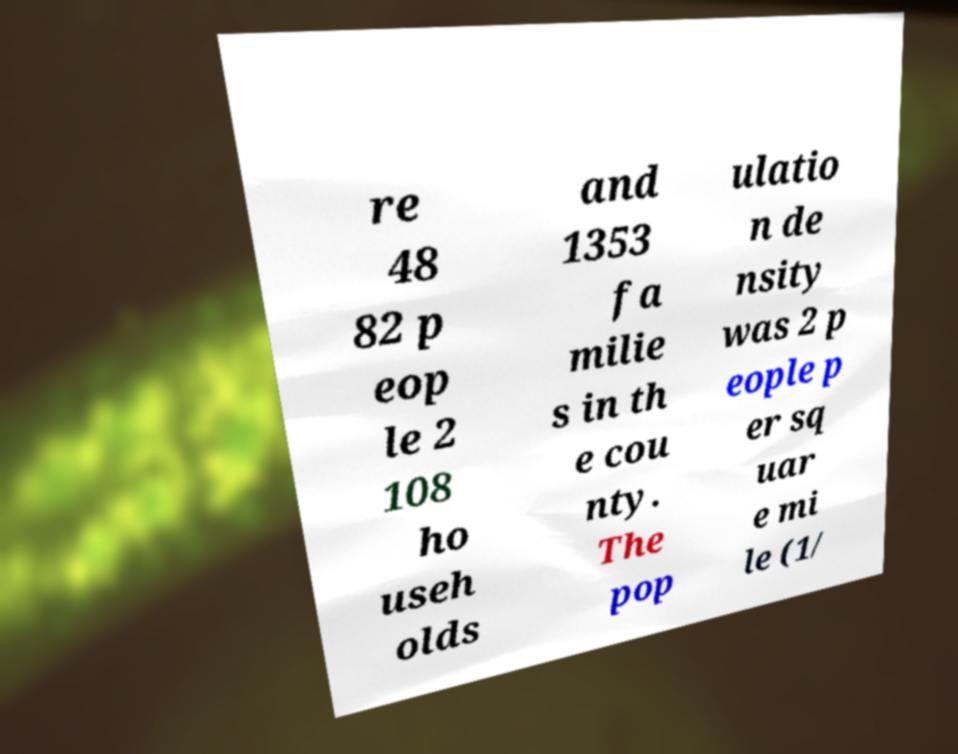For documentation purposes, I need the text within this image transcribed. Could you provide that? re 48 82 p eop le 2 108 ho useh olds and 1353 fa milie s in th e cou nty. The pop ulatio n de nsity was 2 p eople p er sq uar e mi le (1/ 